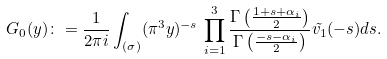Convert formula to latex. <formula><loc_0><loc_0><loc_500><loc_500>G _ { 0 } ( y ) \colon = \frac { 1 } { 2 \pi i } \int _ { ( \sigma ) } ( \pi ^ { 3 } y ) ^ { - s } \, \prod _ { i = 1 } ^ { 3 } \frac { \Gamma \left ( \frac { 1 + s + { \alpha } _ { i } } { 2 } \right ) } { \Gamma \left ( \frac { - s - { \alpha } _ { i } } { 2 } \right ) } \tilde { v _ { 1 } } ( - s ) d s .</formula> 